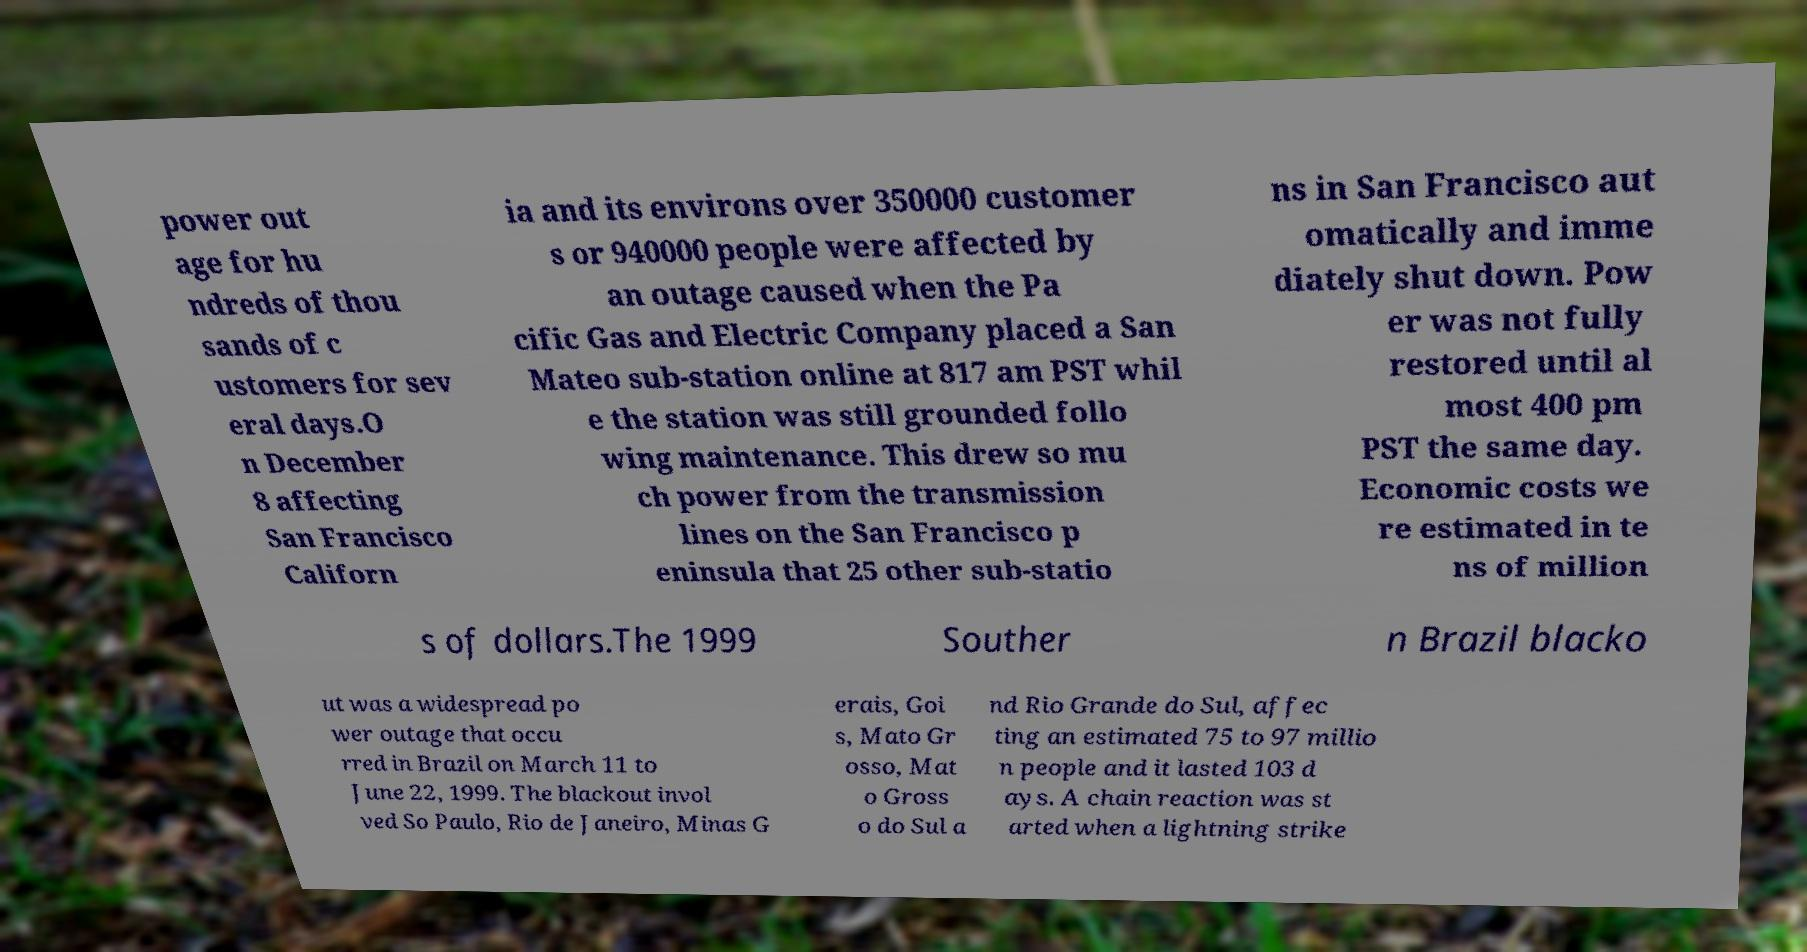Could you assist in decoding the text presented in this image and type it out clearly? power out age for hu ndreds of thou sands of c ustomers for sev eral days.O n December 8 affecting San Francisco Californ ia and its environs over 350000 customer s or 940000 people were affected by an outage caused when the Pa cific Gas and Electric Company placed a San Mateo sub-station online at 817 am PST whil e the station was still grounded follo wing maintenance. This drew so mu ch power from the transmission lines on the San Francisco p eninsula that 25 other sub-statio ns in San Francisco aut omatically and imme diately shut down. Pow er was not fully restored until al most 400 pm PST the same day. Economic costs we re estimated in te ns of million s of dollars.The 1999 Souther n Brazil blacko ut was a widespread po wer outage that occu rred in Brazil on March 11 to June 22, 1999. The blackout invol ved So Paulo, Rio de Janeiro, Minas G erais, Goi s, Mato Gr osso, Mat o Gross o do Sul a nd Rio Grande do Sul, affec ting an estimated 75 to 97 millio n people and it lasted 103 d ays. A chain reaction was st arted when a lightning strike 